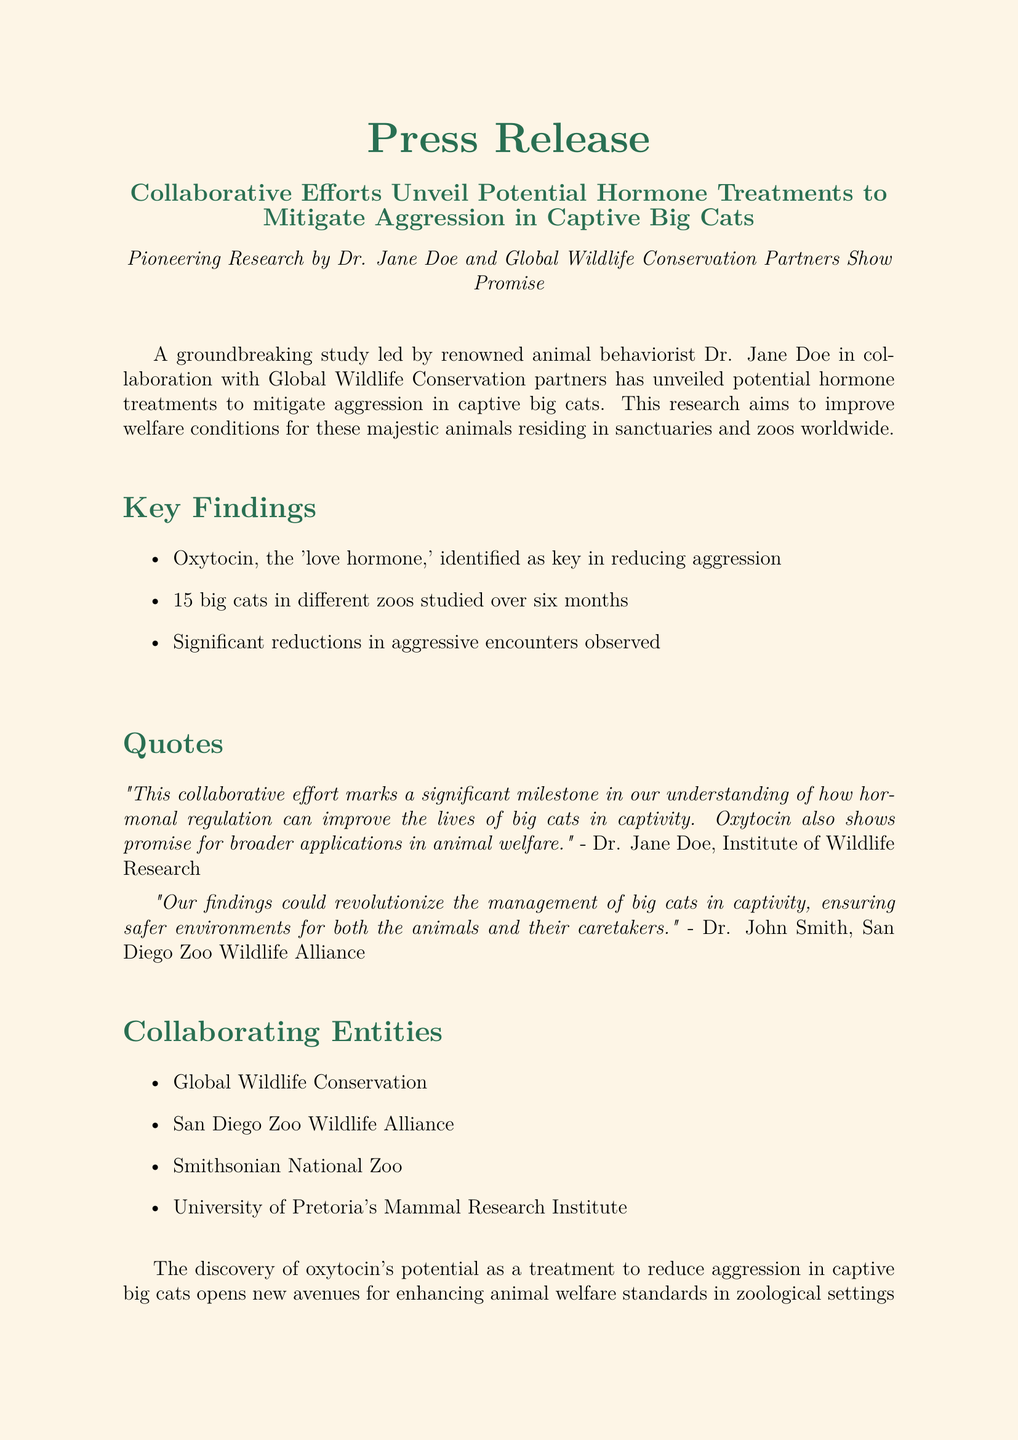What is the main target of the study? The study aims to mitigate aggression in captive big cats.
Answer: Mitigate aggression Who led the study? The document states that the study was led by Dr. Jane Doe.
Answer: Dr. Jane Doe How many big cats were studied? The number of big cats involved in the study was stated in the document as 15.
Answer: 15 What hormone was identified as key in reducing aggression? The document identifies oxytocin as the significant hormone for reducing aggression.
Answer: Oxytocin Which organization is NOT listed as a collaborating entity? The document includes many collaborating entities but does not mention the World Wildlife Fund.
Answer: World Wildlife Fund What is the duration of the study? The document specifies that the study was conducted over six months.
Answer: Six months What potential outcome could the findings revolutionize? The findings could revolutionize the management of big cats in captivity.
Answer: Management of big cats What does Dr. Jane Doe suggest the collaborative effort marks? Dr. Jane Doe suggests that this effort marks a significant milestone in understanding hormonal regulation.
Answer: A significant milestone What contact information is provided for Dr. Jane Doe? The document provides an email and phone number as contact information for Dr. Jane Doe.
Answer: jane.doe@wildliferesearch.org, +1-555-123-4567 